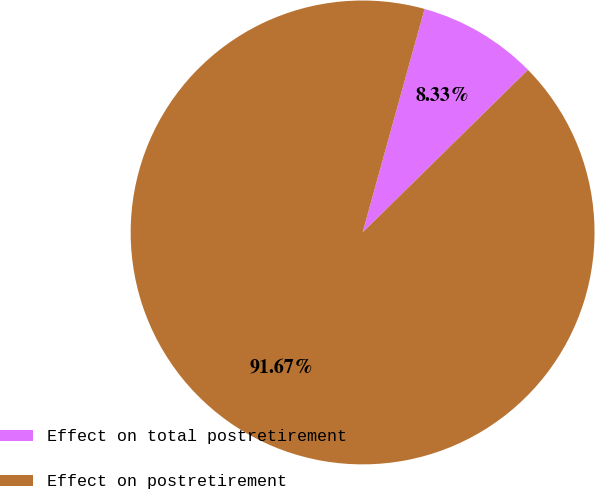Convert chart to OTSL. <chart><loc_0><loc_0><loc_500><loc_500><pie_chart><fcel>Effect on total postretirement<fcel>Effect on postretirement<nl><fcel>8.33%<fcel>91.67%<nl></chart> 